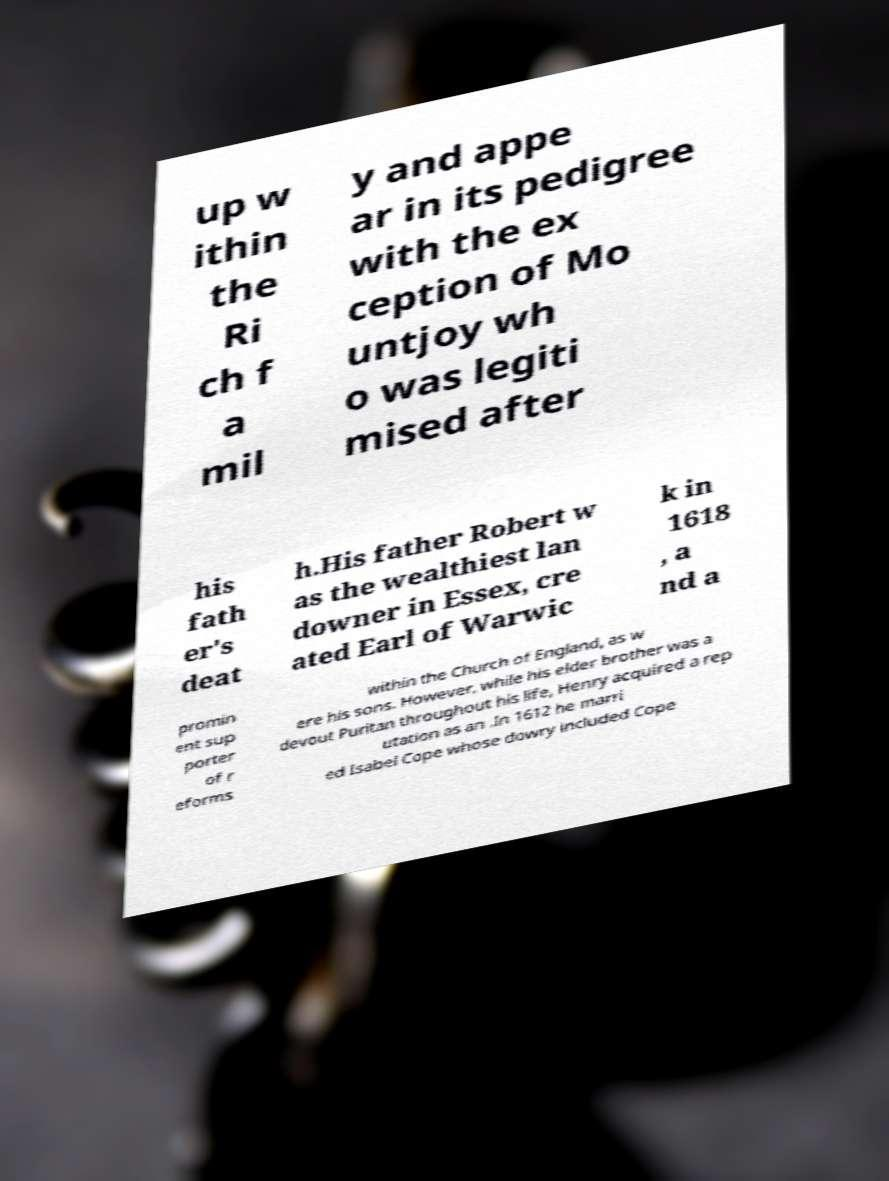There's text embedded in this image that I need extracted. Can you transcribe it verbatim? up w ithin the Ri ch f a mil y and appe ar in its pedigree with the ex ception of Mo untjoy wh o was legiti mised after his fath er's deat h.His father Robert w as the wealthiest lan downer in Essex, cre ated Earl of Warwic k in 1618 , a nd a promin ent sup porter of r eforms within the Church of England, as w ere his sons. However, while his elder brother was a devout Puritan throughout his life, Henry acquired a rep utation as an .In 1612 he marri ed Isabel Cope whose dowry included Cope 